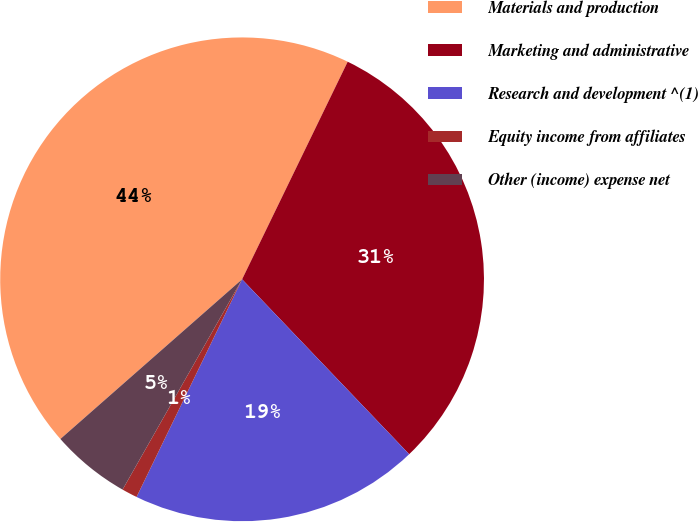Convert chart to OTSL. <chart><loc_0><loc_0><loc_500><loc_500><pie_chart><fcel>Materials and production<fcel>Marketing and administrative<fcel>Research and development ^(1)<fcel>Equity income from affiliates<fcel>Other (income) expense net<nl><fcel>43.66%<fcel>30.67%<fcel>19.32%<fcel>1.04%<fcel>5.3%<nl></chart> 